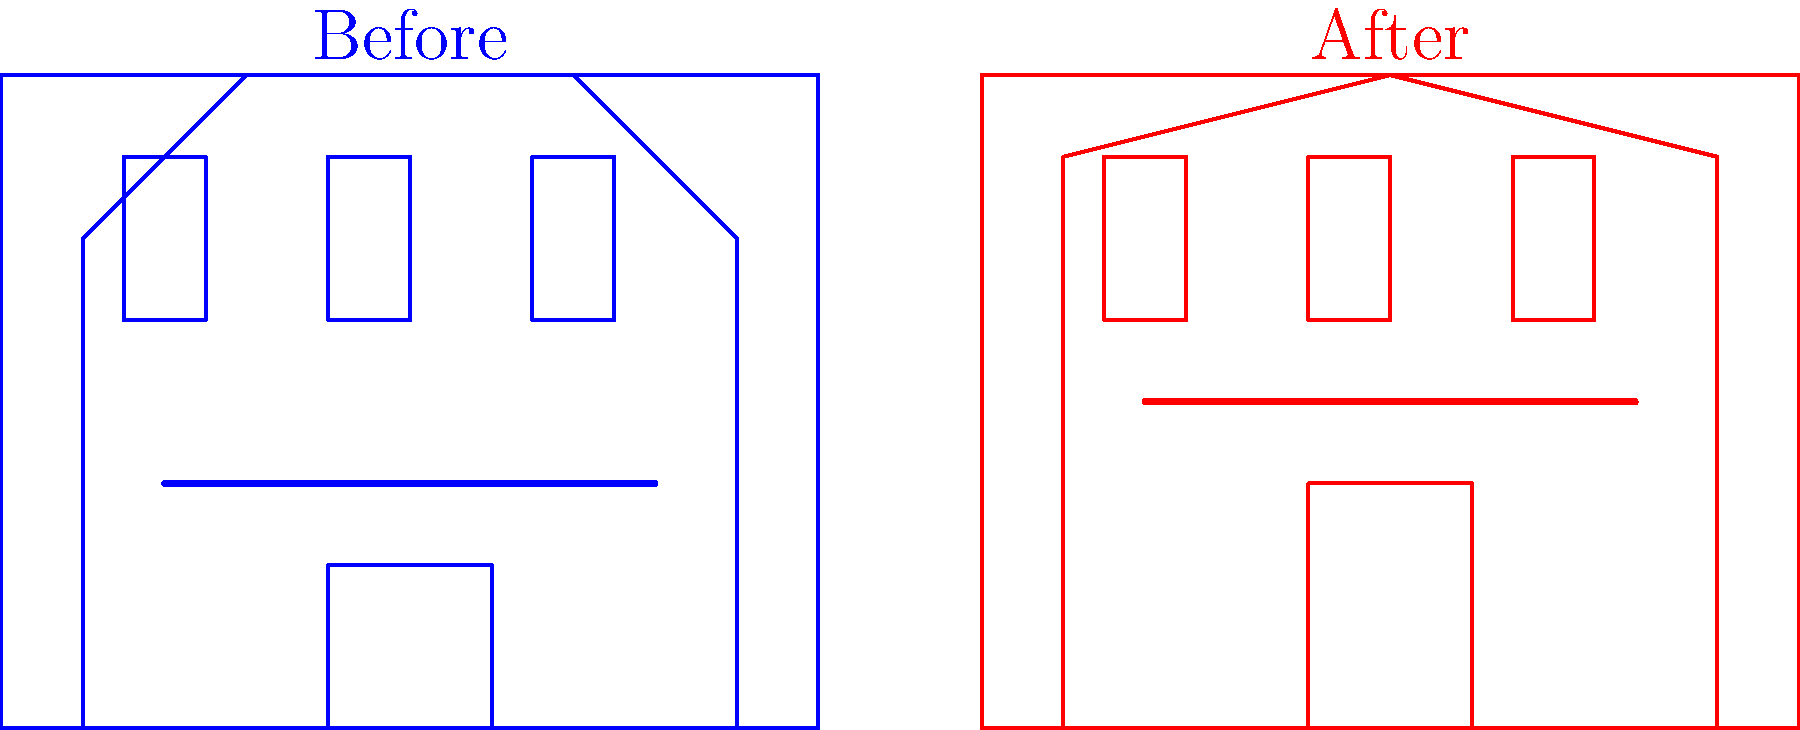Based on the before-and-after diagrams of the Virginia Theatre's facade, what are the three most significant architectural changes made during the renovation? To answer this question, we need to carefully analyze the before-and-after diagrams of the Virginia Theatre's facade. Let's examine the key differences step-by-step:

1. Roofline:
   - Before: The roofline had a more complex shape with multiple angles and a central peak.
   - After: The roofline has been simplified to a more streamlined, gently curved shape.

2. Marquee:
   - Before: The marquee was positioned lower on the facade and appeared to be smaller.
   - After: The marquee has been raised and enlarged, becoming a more prominent feature of the facade.

3. Entrance:
   - Before: The main entrance was shorter and less pronounced.
   - After: The entrance has been heightened and widened, creating a more grand and inviting entryway.

4. Windows:
   - Before: There were three separate, smaller windows across the upper facade.
   - After: The windows have been slightly enlarged and appear to be more integrated into the overall design.

5. Decorative elements:
   - Before: The facade had more ornate decorative features, particularly around the roofline and upper portion.
   - After: Many decorative elements have been removed or simplified, giving the facade a more modern appearance.

While all these changes are notable, the three most significant architectural modifications are:
1. The simplification and reshaping of the roofline
2. The enlargement and repositioning of the marquee
3. The expansion and enhancement of the main entrance

These changes have the most substantial impact on the overall appearance and function of the theater's facade.
Answer: Simplified roofline, enlarged marquee, expanded entrance 